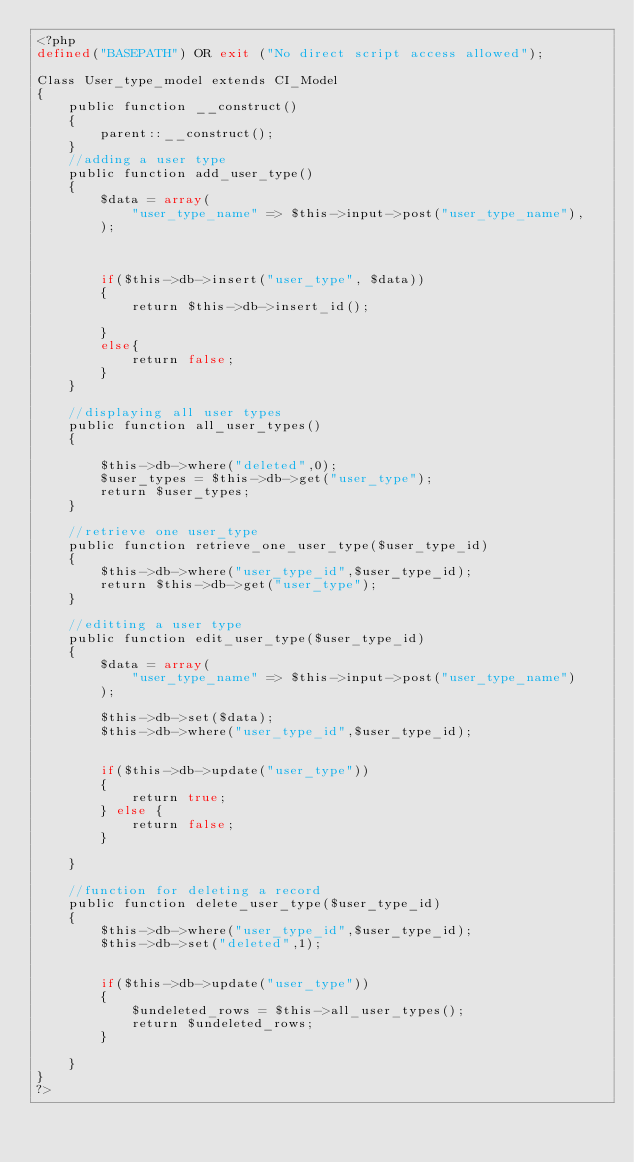Convert code to text. <code><loc_0><loc_0><loc_500><loc_500><_PHP_><?php 
defined("BASEPATH") OR exit ("No direct script access allowed");

Class User_type_model extends CI_Model
{
    public function __construct()
    {
        parent::__construct();
    }
    //adding a user type
    public function add_user_type()
    {
        $data = array(
            "user_type_name" => $this->input->post("user_type_name"),
        );

        

        if($this->db->insert("user_type", $data))
        {
            return $this->db->insert_id();
            
        }
        else{
            return false;
        }       
    }

    //displaying all user types
    public function all_user_types()
    {
        
        $this->db->where("deleted",0);
        $user_types = $this->db->get("user_type");
        return $user_types;
    }

    //retrieve one user_type
    public function retrieve_one_user_type($user_type_id)
    {
        $this->db->where("user_type_id",$user_type_id);
        return $this->db->get("user_type");
    }

    //editting a user type
    public function edit_user_type($user_type_id)
    {
        $data = array(
            "user_type_name" => $this->input->post("user_type_name")
        );

        $this->db->set($data);
        $this->db->where("user_type_id",$user_type_id);

        
        if($this->db->update("user_type"))
        {
            return true;
        } else {
            return false;
        }
        
    }

    //function for deleting a record
    public function delete_user_type($user_type_id)
    {
        $this->db->where("user_type_id",$user_type_id);
        $this->db->set("deleted",1);
        

        if($this->db->update("user_type"))
        {
            $undeleted_rows = $this->all_user_types();
            return $undeleted_rows;
        }

    }
}
?></code> 